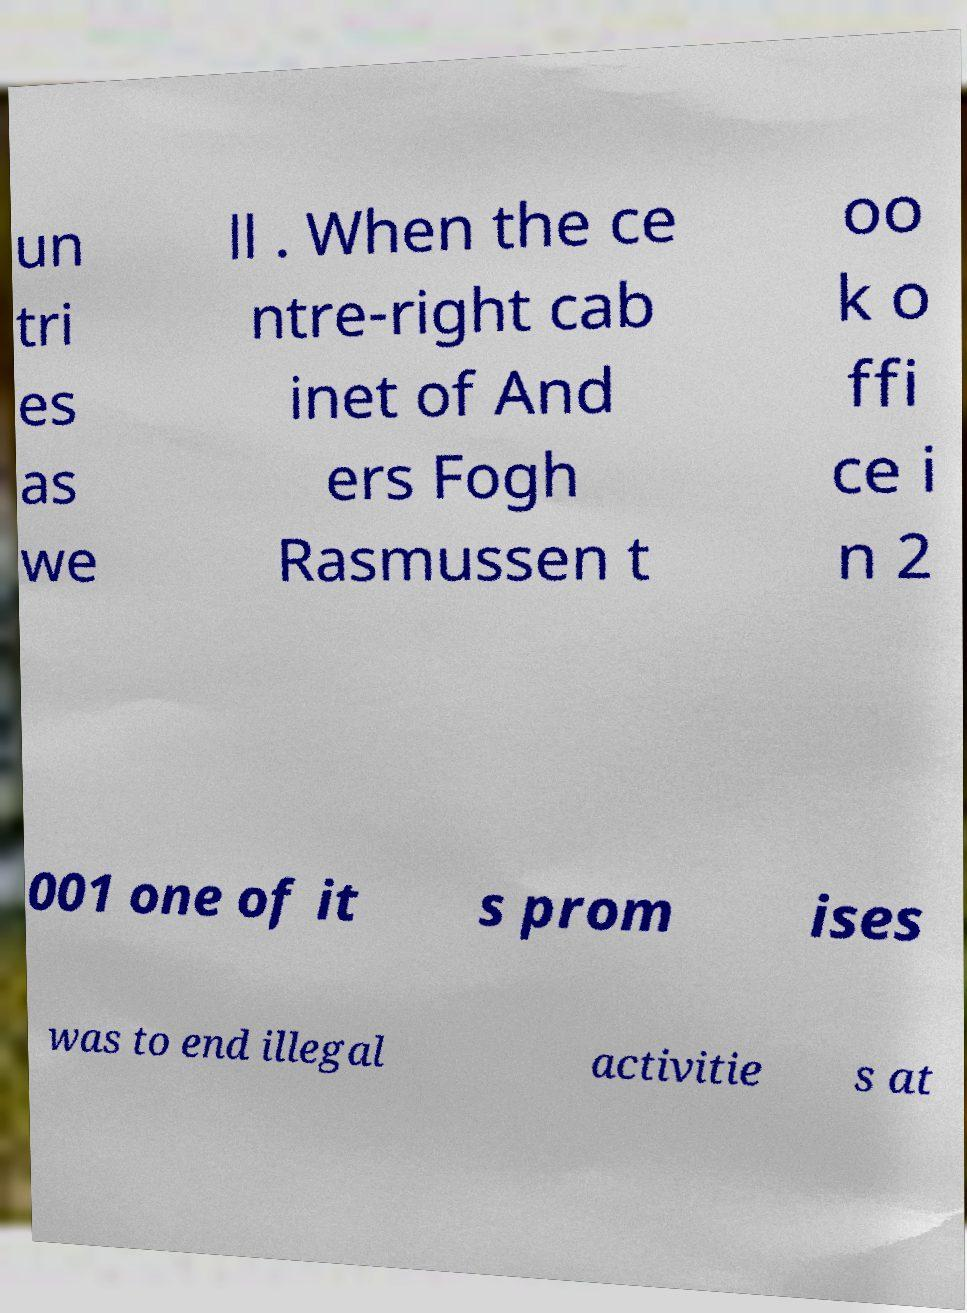Please read and relay the text visible in this image. What does it say? un tri es as we ll . When the ce ntre-right cab inet of And ers Fogh Rasmussen t oo k o ffi ce i n 2 001 one of it s prom ises was to end illegal activitie s at 